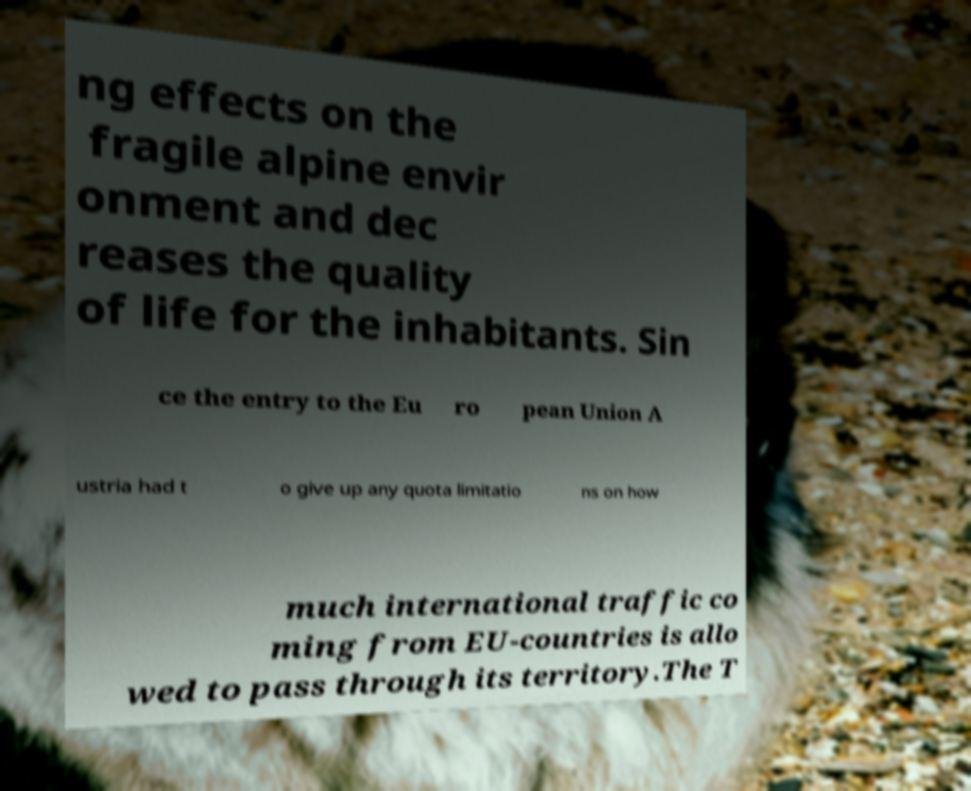I need the written content from this picture converted into text. Can you do that? ng effects on the fragile alpine envir onment and dec reases the quality of life for the inhabitants. Sin ce the entry to the Eu ro pean Union A ustria had t o give up any quota limitatio ns on how much international traffic co ming from EU-countries is allo wed to pass through its territory.The T 